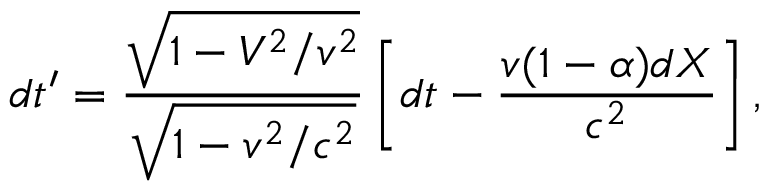<formula> <loc_0><loc_0><loc_500><loc_500>d t ^ { \prime } = \frac { \sqrt { 1 - V ^ { 2 } / v ^ { 2 } } } { \sqrt { 1 - v ^ { 2 } / c ^ { 2 } } } \left [ d t - \frac { v ( 1 - \alpha ) d X } { c ^ { 2 } } \right ] ,</formula> 